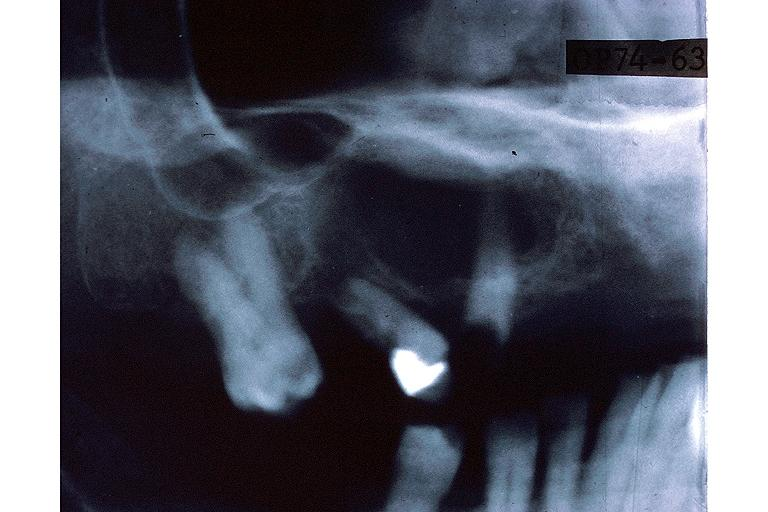where is this?
Answer the question using a single word or phrase. Oral 